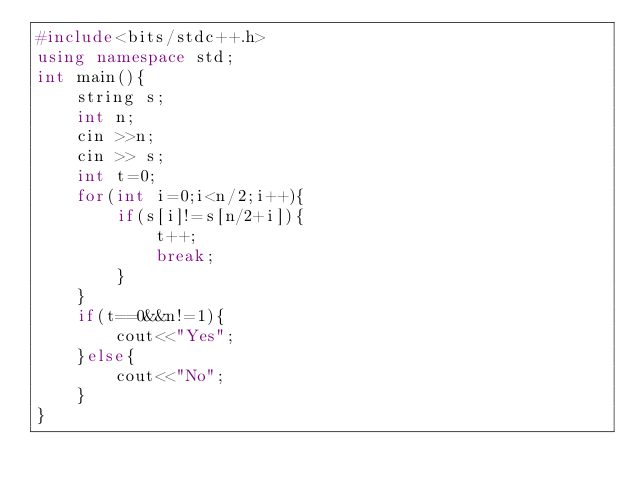<code> <loc_0><loc_0><loc_500><loc_500><_C++_>#include<bits/stdc++.h>
using namespace std;
int main(){
	string s;
	int n;
	cin >>n;
	cin >> s;
	int t=0;
	for(int i=0;i<n/2;i++){
		if(s[i]!=s[n/2+i]){
			t++;
			break;
		}
	}
	if(t==0&&n!=1){
		cout<<"Yes";
	}else{
		cout<<"No";
	}
}</code> 